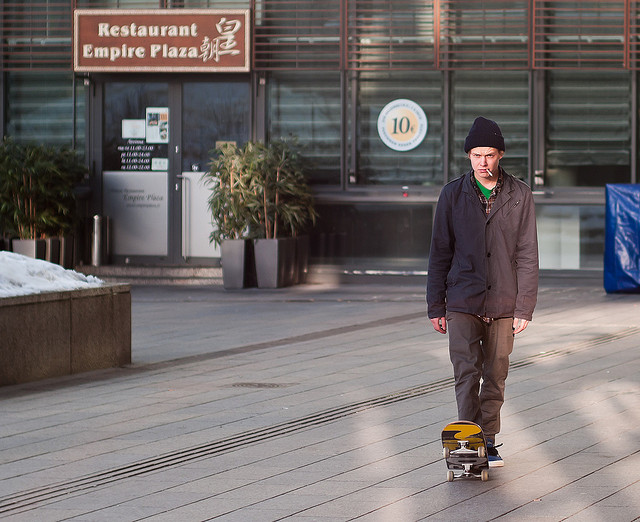Please extract the text content from this image. Restaurant Plaza 10 